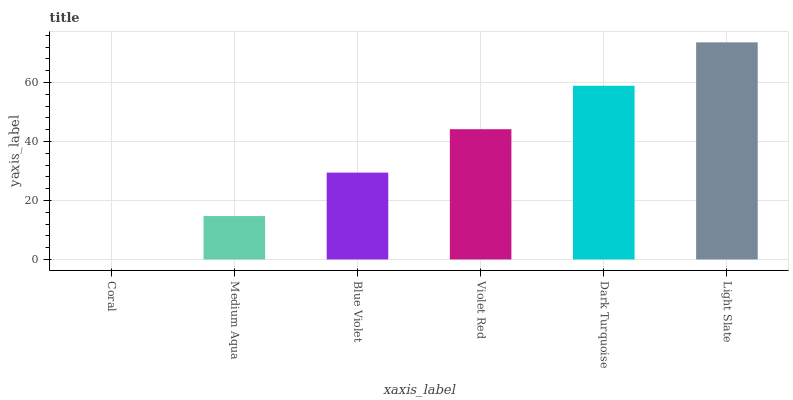Is Coral the minimum?
Answer yes or no. Yes. Is Light Slate the maximum?
Answer yes or no. Yes. Is Medium Aqua the minimum?
Answer yes or no. No. Is Medium Aqua the maximum?
Answer yes or no. No. Is Medium Aqua greater than Coral?
Answer yes or no. Yes. Is Coral less than Medium Aqua?
Answer yes or no. Yes. Is Coral greater than Medium Aqua?
Answer yes or no. No. Is Medium Aqua less than Coral?
Answer yes or no. No. Is Violet Red the high median?
Answer yes or no. Yes. Is Blue Violet the low median?
Answer yes or no. Yes. Is Blue Violet the high median?
Answer yes or no. No. Is Coral the low median?
Answer yes or no. No. 